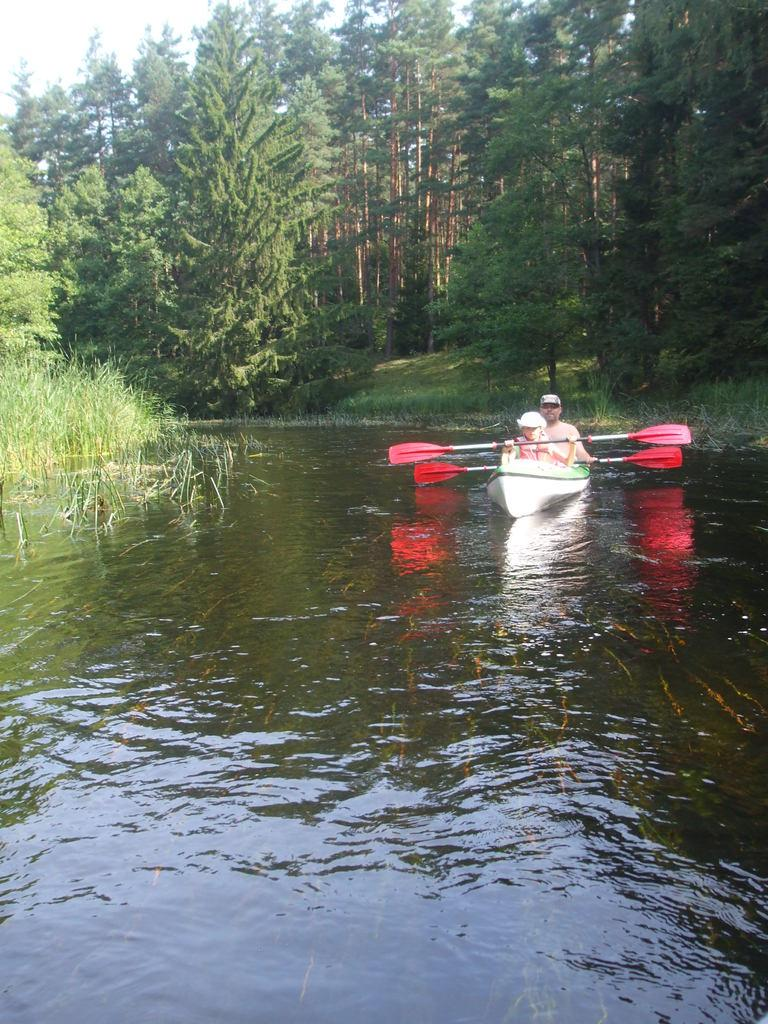What are the persons in the boat doing? The persons in the boat are carrying rows in their hands. What can be seen in the background of the image? There are trees, the sky, grass, and water visible in the background of the image. How many persons are in the boat? The number of persons in the boat cannot be determined from the provided facts. What type of soup is being served in the boat? There is no soup present in the image; it features persons sitting in a boat and carrying rows. Can you tell me how many rats are visible in the image? There are no rats present in the image. 